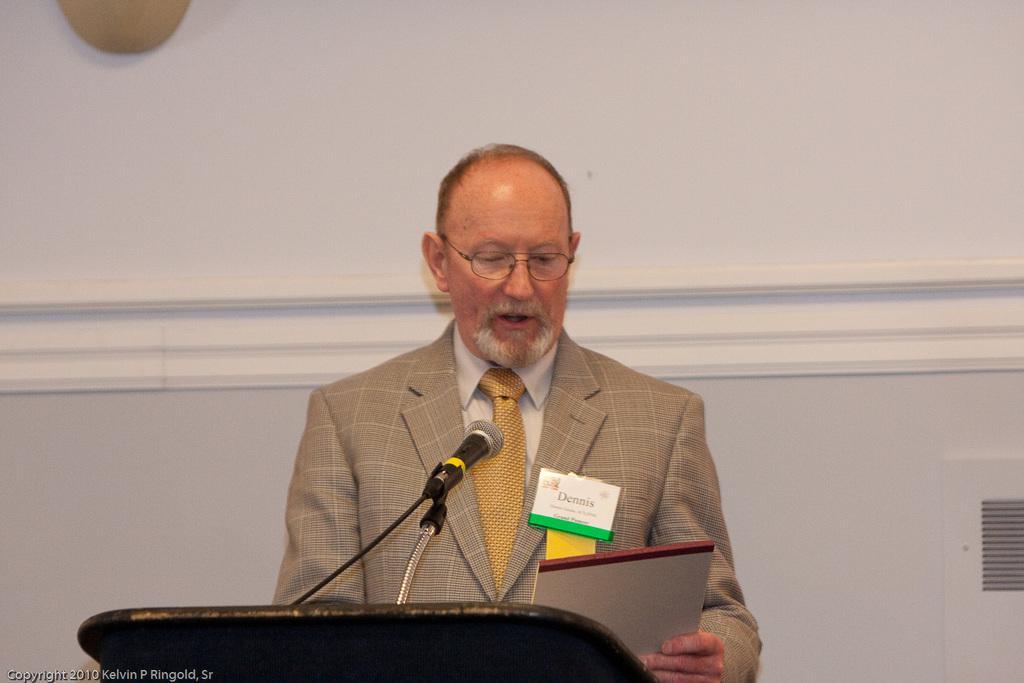Could you give a brief overview of what you see in this image? In this image I can see a man is standing and I can see he is wearing formal dress and specs. I can also see he is holding a white colour thing and on his dress I can see something is written on a white colour thing. In the front of him I can see a mic and a black colour thing. I can also see a white colour wall in the background and on the bottom left corner of this image I can see a watermark. 